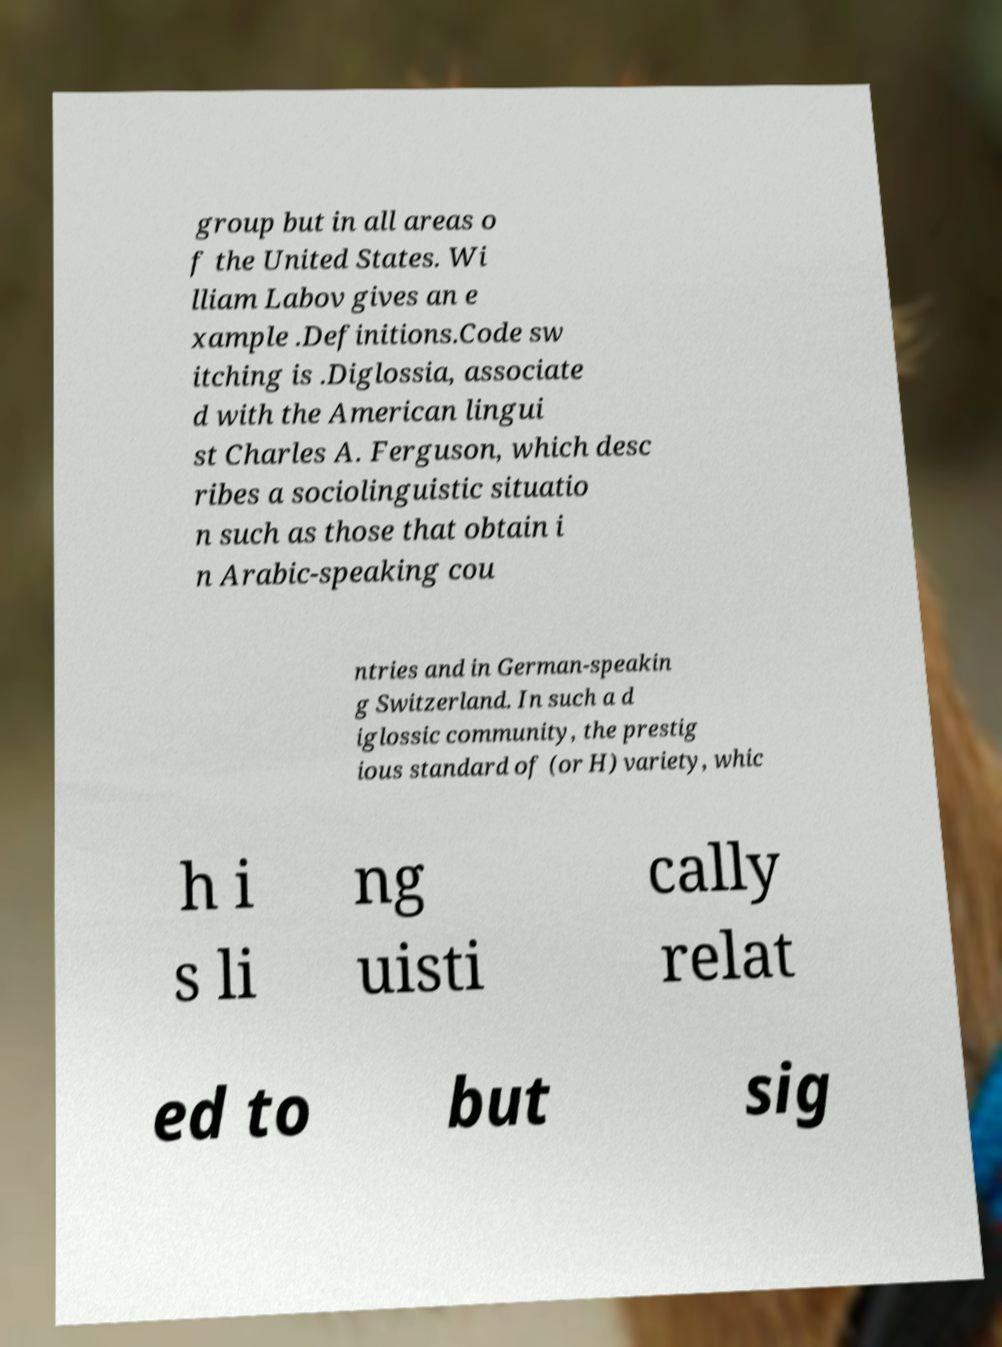For documentation purposes, I need the text within this image transcribed. Could you provide that? group but in all areas o f the United States. Wi lliam Labov gives an e xample .Definitions.Code sw itching is .Diglossia, associate d with the American lingui st Charles A. Ferguson, which desc ribes a sociolinguistic situatio n such as those that obtain i n Arabic-speaking cou ntries and in German-speakin g Switzerland. In such a d iglossic community, the prestig ious standard of (or H) variety, whic h i s li ng uisti cally relat ed to but sig 